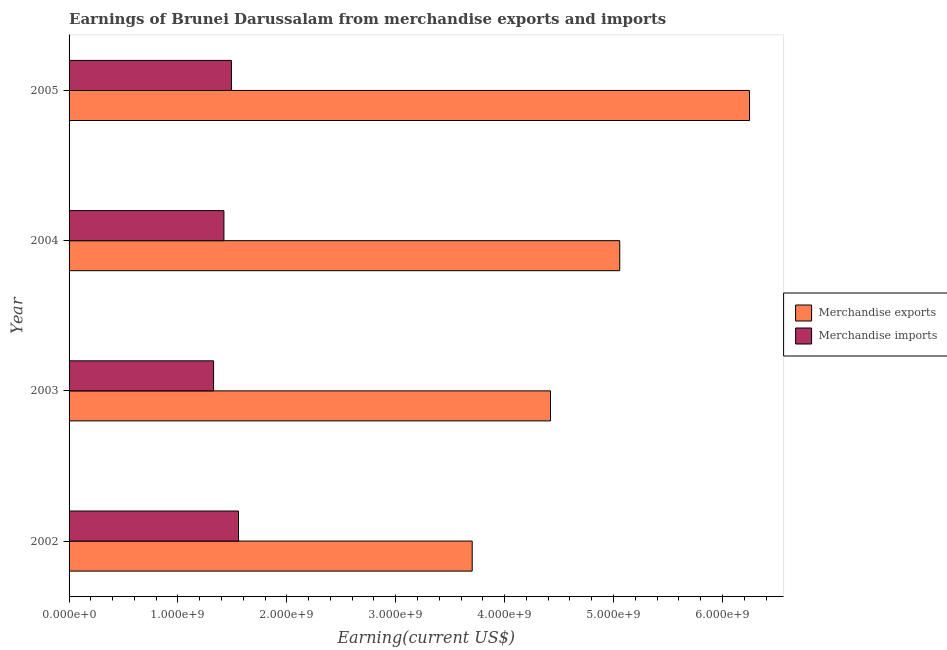How many groups of bars are there?
Offer a very short reply. 4. How many bars are there on the 1st tick from the bottom?
Offer a very short reply. 2. What is the earnings from merchandise imports in 2002?
Provide a succinct answer. 1.56e+09. Across all years, what is the maximum earnings from merchandise exports?
Make the answer very short. 6.25e+09. Across all years, what is the minimum earnings from merchandise exports?
Ensure brevity in your answer.  3.70e+09. In which year was the earnings from merchandise exports maximum?
Your answer should be very brief. 2005. What is the total earnings from merchandise imports in the graph?
Offer a terse response. 5.80e+09. What is the difference between the earnings from merchandise exports in 2002 and that in 2004?
Provide a succinct answer. -1.36e+09. What is the difference between the earnings from merchandise imports in 2004 and the earnings from merchandise exports in 2003?
Keep it short and to the point. -3.00e+09. What is the average earnings from merchandise exports per year?
Your answer should be compact. 4.86e+09. In the year 2004, what is the difference between the earnings from merchandise imports and earnings from merchandise exports?
Offer a terse response. -3.64e+09. What is the ratio of the earnings from merchandise exports in 2002 to that in 2005?
Ensure brevity in your answer.  0.59. Is the earnings from merchandise imports in 2002 less than that in 2004?
Your response must be concise. No. Is the difference between the earnings from merchandise exports in 2002 and 2005 greater than the difference between the earnings from merchandise imports in 2002 and 2005?
Make the answer very short. No. What is the difference between the highest and the second highest earnings from merchandise exports?
Provide a short and direct response. 1.19e+09. What is the difference between the highest and the lowest earnings from merchandise exports?
Your answer should be compact. 2.55e+09. What does the 1st bar from the top in 2002 represents?
Offer a very short reply. Merchandise imports. What does the 1st bar from the bottom in 2004 represents?
Provide a succinct answer. Merchandise exports. How many bars are there?
Ensure brevity in your answer.  8. What is the difference between two consecutive major ticks on the X-axis?
Keep it short and to the point. 1.00e+09. Does the graph contain any zero values?
Make the answer very short. No. Where does the legend appear in the graph?
Make the answer very short. Center right. How are the legend labels stacked?
Your answer should be compact. Vertical. What is the title of the graph?
Offer a terse response. Earnings of Brunei Darussalam from merchandise exports and imports. What is the label or title of the X-axis?
Keep it short and to the point. Earning(current US$). What is the label or title of the Y-axis?
Provide a succinct answer. Year. What is the Earning(current US$) in Merchandise exports in 2002?
Your answer should be compact. 3.70e+09. What is the Earning(current US$) of Merchandise imports in 2002?
Keep it short and to the point. 1.56e+09. What is the Earning(current US$) in Merchandise exports in 2003?
Ensure brevity in your answer.  4.42e+09. What is the Earning(current US$) of Merchandise imports in 2003?
Your answer should be compact. 1.33e+09. What is the Earning(current US$) in Merchandise exports in 2004?
Provide a succinct answer. 5.06e+09. What is the Earning(current US$) in Merchandise imports in 2004?
Ensure brevity in your answer.  1.42e+09. What is the Earning(current US$) in Merchandise exports in 2005?
Your response must be concise. 6.25e+09. What is the Earning(current US$) of Merchandise imports in 2005?
Ensure brevity in your answer.  1.49e+09. Across all years, what is the maximum Earning(current US$) of Merchandise exports?
Your answer should be very brief. 6.25e+09. Across all years, what is the maximum Earning(current US$) of Merchandise imports?
Give a very brief answer. 1.56e+09. Across all years, what is the minimum Earning(current US$) in Merchandise exports?
Ensure brevity in your answer.  3.70e+09. Across all years, what is the minimum Earning(current US$) in Merchandise imports?
Your response must be concise. 1.33e+09. What is the total Earning(current US$) of Merchandise exports in the graph?
Ensure brevity in your answer.  1.94e+1. What is the total Earning(current US$) in Merchandise imports in the graph?
Provide a short and direct response. 5.80e+09. What is the difference between the Earning(current US$) of Merchandise exports in 2002 and that in 2003?
Your answer should be compact. -7.19e+08. What is the difference between the Earning(current US$) of Merchandise imports in 2002 and that in 2003?
Provide a succinct answer. 2.29e+08. What is the difference between the Earning(current US$) in Merchandise exports in 2002 and that in 2004?
Keep it short and to the point. -1.36e+09. What is the difference between the Earning(current US$) in Merchandise imports in 2002 and that in 2004?
Ensure brevity in your answer.  1.34e+08. What is the difference between the Earning(current US$) of Merchandise exports in 2002 and that in 2005?
Your response must be concise. -2.55e+09. What is the difference between the Earning(current US$) of Merchandise imports in 2002 and that in 2005?
Give a very brief answer. 6.50e+07. What is the difference between the Earning(current US$) of Merchandise exports in 2003 and that in 2004?
Provide a short and direct response. -6.36e+08. What is the difference between the Earning(current US$) of Merchandise imports in 2003 and that in 2004?
Provide a short and direct response. -9.50e+07. What is the difference between the Earning(current US$) in Merchandise exports in 2003 and that in 2005?
Your answer should be very brief. -1.83e+09. What is the difference between the Earning(current US$) of Merchandise imports in 2003 and that in 2005?
Provide a succinct answer. -1.64e+08. What is the difference between the Earning(current US$) in Merchandise exports in 2004 and that in 2005?
Keep it short and to the point. -1.19e+09. What is the difference between the Earning(current US$) of Merchandise imports in 2004 and that in 2005?
Keep it short and to the point. -6.90e+07. What is the difference between the Earning(current US$) in Merchandise exports in 2002 and the Earning(current US$) in Merchandise imports in 2003?
Offer a very short reply. 2.38e+09. What is the difference between the Earning(current US$) in Merchandise exports in 2002 and the Earning(current US$) in Merchandise imports in 2004?
Provide a short and direct response. 2.28e+09. What is the difference between the Earning(current US$) of Merchandise exports in 2002 and the Earning(current US$) of Merchandise imports in 2005?
Your answer should be very brief. 2.21e+09. What is the difference between the Earning(current US$) in Merchandise exports in 2003 and the Earning(current US$) in Merchandise imports in 2004?
Your answer should be very brief. 3.00e+09. What is the difference between the Earning(current US$) in Merchandise exports in 2003 and the Earning(current US$) in Merchandise imports in 2005?
Offer a terse response. 2.93e+09. What is the difference between the Earning(current US$) of Merchandise exports in 2004 and the Earning(current US$) of Merchandise imports in 2005?
Provide a short and direct response. 3.57e+09. What is the average Earning(current US$) of Merchandise exports per year?
Offer a terse response. 4.86e+09. What is the average Earning(current US$) in Merchandise imports per year?
Give a very brief answer. 1.45e+09. In the year 2002, what is the difference between the Earning(current US$) of Merchandise exports and Earning(current US$) of Merchandise imports?
Make the answer very short. 2.15e+09. In the year 2003, what is the difference between the Earning(current US$) of Merchandise exports and Earning(current US$) of Merchandise imports?
Your response must be concise. 3.09e+09. In the year 2004, what is the difference between the Earning(current US$) of Merchandise exports and Earning(current US$) of Merchandise imports?
Give a very brief answer. 3.64e+09. In the year 2005, what is the difference between the Earning(current US$) of Merchandise exports and Earning(current US$) of Merchandise imports?
Keep it short and to the point. 4.76e+09. What is the ratio of the Earning(current US$) in Merchandise exports in 2002 to that in 2003?
Make the answer very short. 0.84. What is the ratio of the Earning(current US$) of Merchandise imports in 2002 to that in 2003?
Offer a very short reply. 1.17. What is the ratio of the Earning(current US$) in Merchandise exports in 2002 to that in 2004?
Provide a succinct answer. 0.73. What is the ratio of the Earning(current US$) in Merchandise imports in 2002 to that in 2004?
Your response must be concise. 1.09. What is the ratio of the Earning(current US$) of Merchandise exports in 2002 to that in 2005?
Give a very brief answer. 0.59. What is the ratio of the Earning(current US$) in Merchandise imports in 2002 to that in 2005?
Provide a succinct answer. 1.04. What is the ratio of the Earning(current US$) in Merchandise exports in 2003 to that in 2004?
Make the answer very short. 0.87. What is the ratio of the Earning(current US$) in Merchandise imports in 2003 to that in 2004?
Ensure brevity in your answer.  0.93. What is the ratio of the Earning(current US$) of Merchandise exports in 2003 to that in 2005?
Your response must be concise. 0.71. What is the ratio of the Earning(current US$) in Merchandise imports in 2003 to that in 2005?
Your answer should be very brief. 0.89. What is the ratio of the Earning(current US$) in Merchandise exports in 2004 to that in 2005?
Your answer should be compact. 0.81. What is the ratio of the Earning(current US$) of Merchandise imports in 2004 to that in 2005?
Keep it short and to the point. 0.95. What is the difference between the highest and the second highest Earning(current US$) in Merchandise exports?
Provide a succinct answer. 1.19e+09. What is the difference between the highest and the second highest Earning(current US$) of Merchandise imports?
Provide a succinct answer. 6.50e+07. What is the difference between the highest and the lowest Earning(current US$) of Merchandise exports?
Your response must be concise. 2.55e+09. What is the difference between the highest and the lowest Earning(current US$) in Merchandise imports?
Your response must be concise. 2.29e+08. 